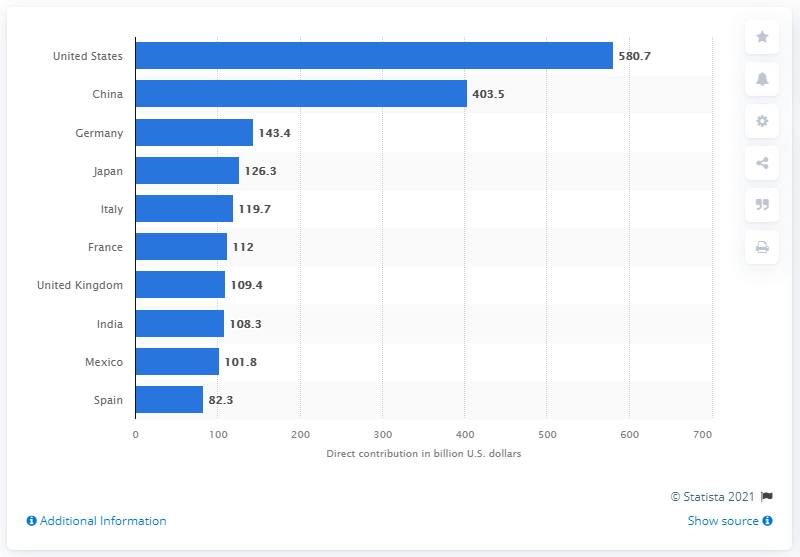Identify some key points in this picture. The second largest contributor to GDP is China. The travel and tourism industry of the United States contributed a total of 580.7 billion dollars to the country's GDP in 2019. 